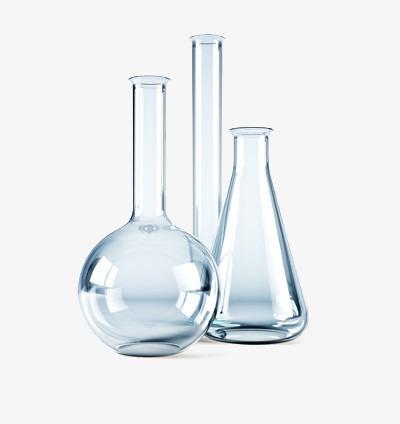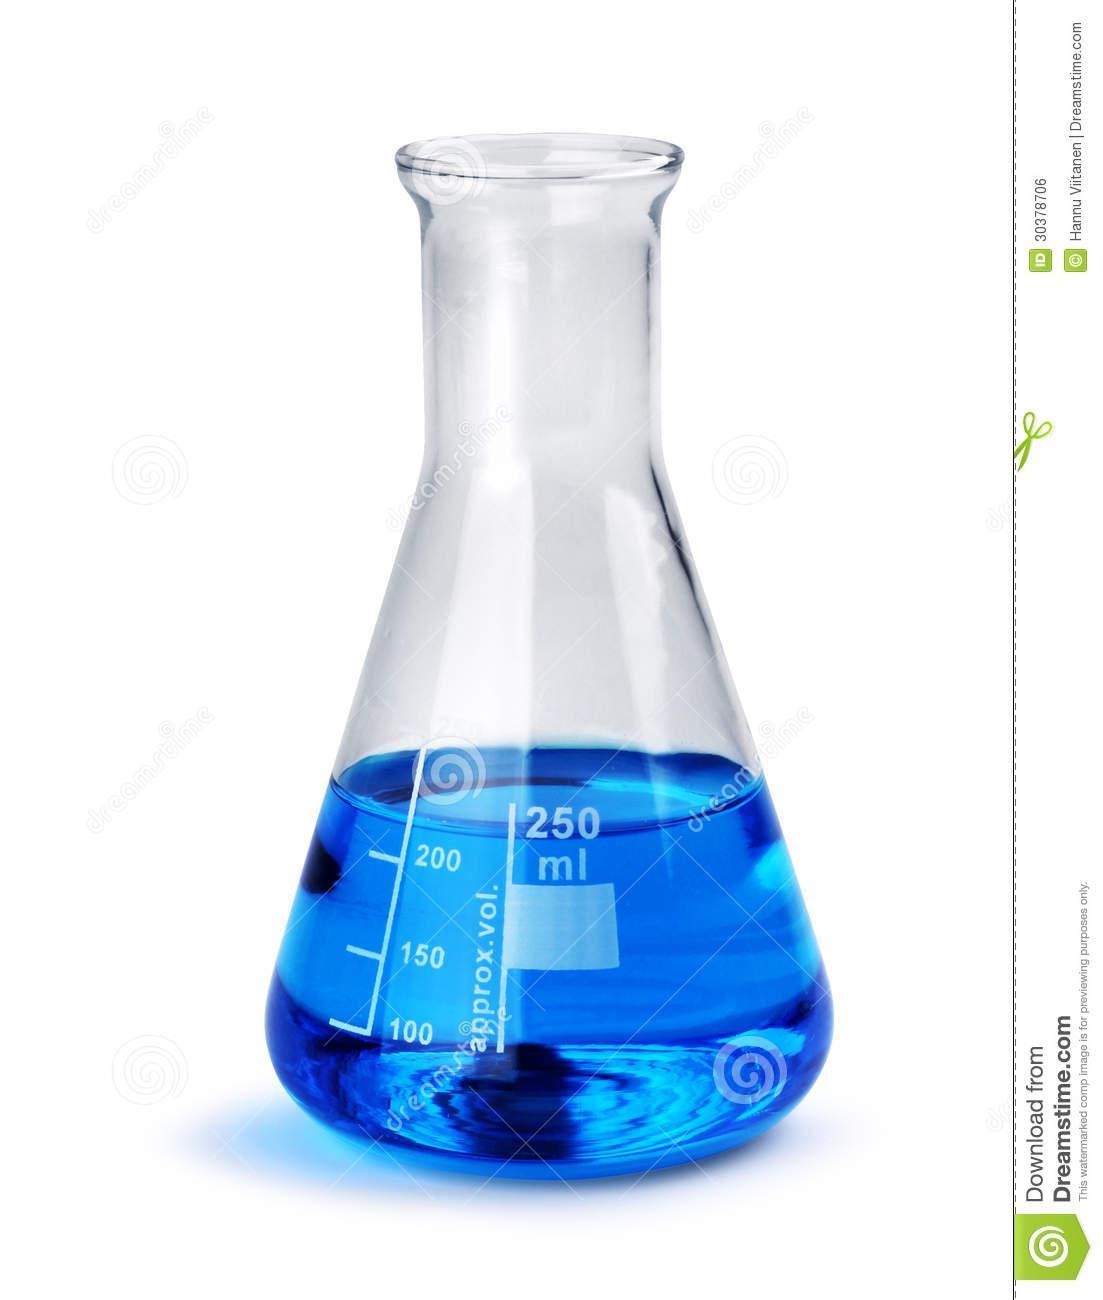The first image is the image on the left, the second image is the image on the right. Considering the images on both sides, is "One of the images has only a single flask, and it has blue liquid in it." valid? Answer yes or no. Yes. 